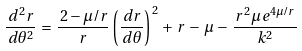<formula> <loc_0><loc_0><loc_500><loc_500>\frac { \, d ^ { 2 } r } { \, d \theta ^ { 2 } } \, = \, \frac { \, 2 - \mu / r } { r } \left ( \frac { \, d r } { \, d \theta } \right ) ^ { \, 2 } \, + \, r \, - \, \mu \, - \, \frac { \, r ^ { 2 } \mu \, e ^ { 4 \mu / r } } { k ^ { 2 } }</formula> 